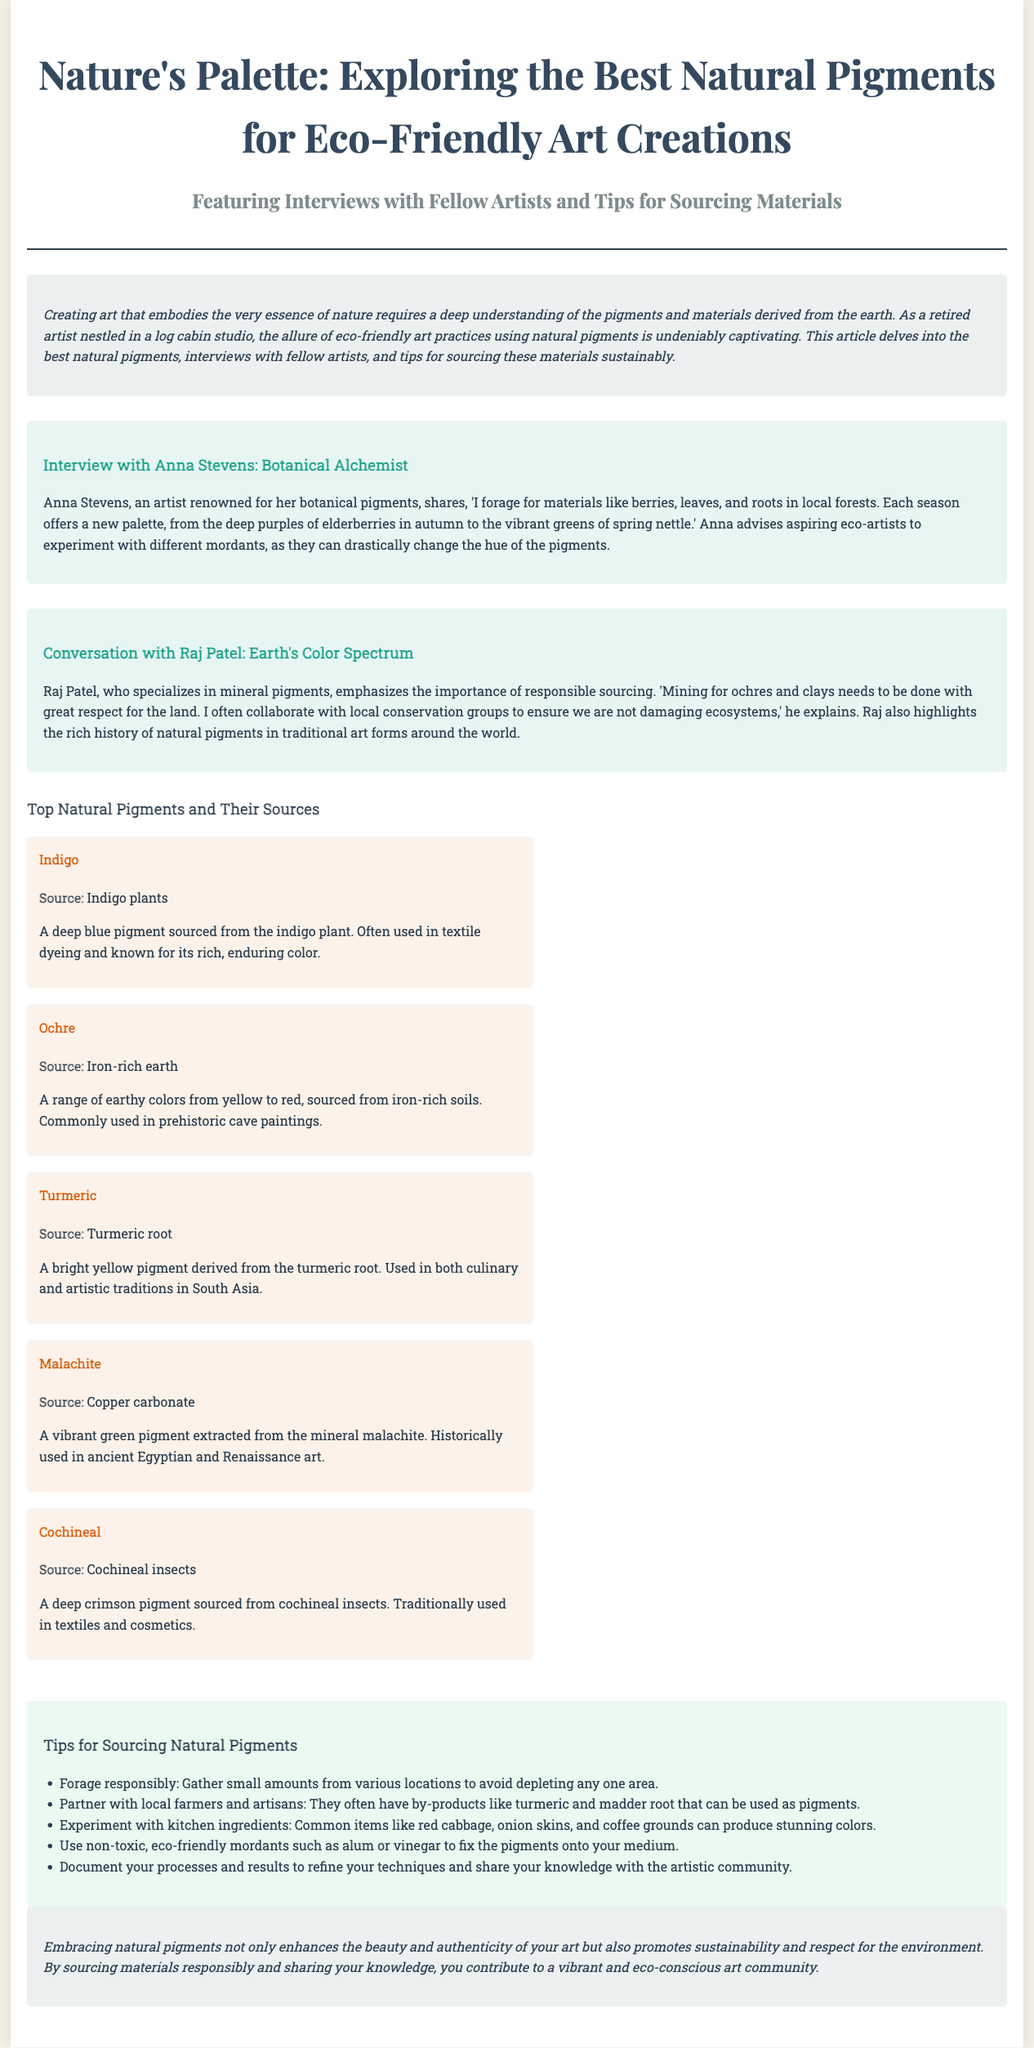What is the title of the article? The title of the article is the primary heading presented in the document, which introduces the main topic.
Answer: Nature's Palette: Exploring the Best Natural Pigments for Eco-Friendly Art Creations Who is the first artist interviewed? This refers to the name of the artist featured in the first interview section of the document.
Answer: Anna Stevens What is the source of Indigo? This question focuses on the specific material source mentioned for Indigo pigment in the article.
Answer: Indigo plants What color does Turmeric produce? This inquiry is about the pigment derived from Turmeric and its characteristic color as stated in the document.
Answer: Bright yellow How does Anna Stevens recommend aspiring eco-artists to experiment? This requires understanding the suggestions made by Anna Stevens about the use of different substances.
Answer: Different mordants What should artists do to source pigments responsibly according to Raj Patel? This requires reasoning about Raj Patel's emphasis on environmental respect in sourcing.
Answer: Collaborate with local conservation groups How many natural pigments are listed in the document? This question pertains to counting the distinct types of natural pigments provided in the article.
Answer: Five What color spectrum does Raj Patel specialize in? This refers to the specific type of pigments Raj Patel works with as mentioned in the interviews.
Answer: Mineral pigments What is one of the tips for sourcing natural pigments? This asks for a specific actionable suggestion given in the tips section to help artists gather natural materials.
Answer: Forage responsibly 